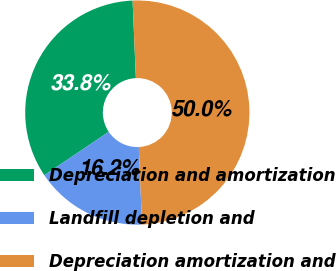<chart> <loc_0><loc_0><loc_500><loc_500><pie_chart><fcel>Depreciation and amortization<fcel>Landfill depletion and<fcel>Depreciation amortization and<nl><fcel>33.77%<fcel>16.23%<fcel>50.0%<nl></chart> 